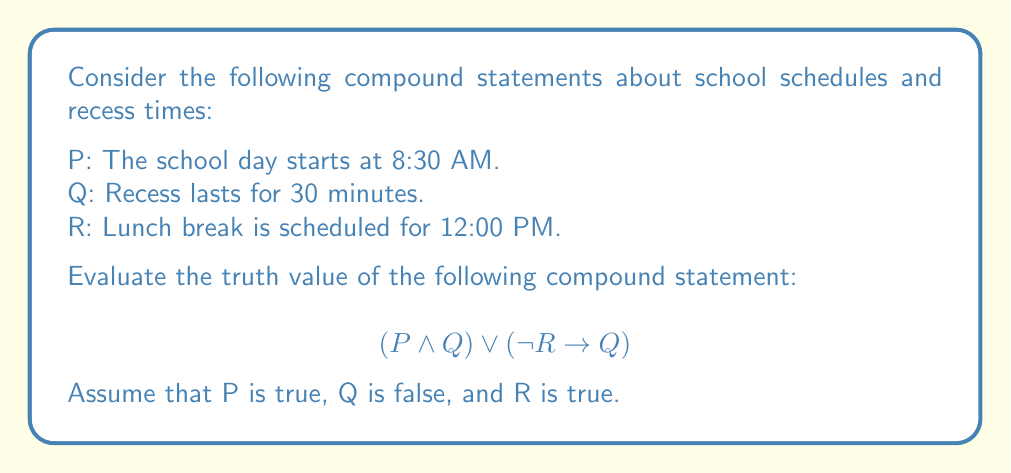What is the answer to this math problem? Let's evaluate this compound statement step by step:

1. First, let's assign truth values to the individual statements:
   P: True
   Q: False
   R: True

2. Now, let's evaluate the first part of the compound statement: $(P \land Q)$
   $True \land False = False$

3. Next, let's evaluate the second part: $(\lnot R \rightarrow Q)$
   - $\lnot R$ is False (since R is True)
   - $False \rightarrow False$ is True (in propositional logic, False implies anything is True)

4. Now we have:
   $False \lor True$

5. The final step is to evaluate the disjunction (OR) of these results:
   $False \lor True = True$

Therefore, the entire compound statement is True.
Answer: True 